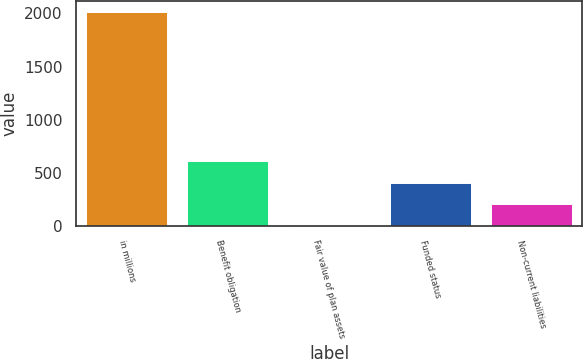Convert chart to OTSL. <chart><loc_0><loc_0><loc_500><loc_500><bar_chart><fcel>in millions<fcel>Benefit obligation<fcel>Fair value of plan assets<fcel>Funded status<fcel>Non-current liabilities<nl><fcel>2011<fcel>609.04<fcel>8.2<fcel>408.76<fcel>208.48<nl></chart> 